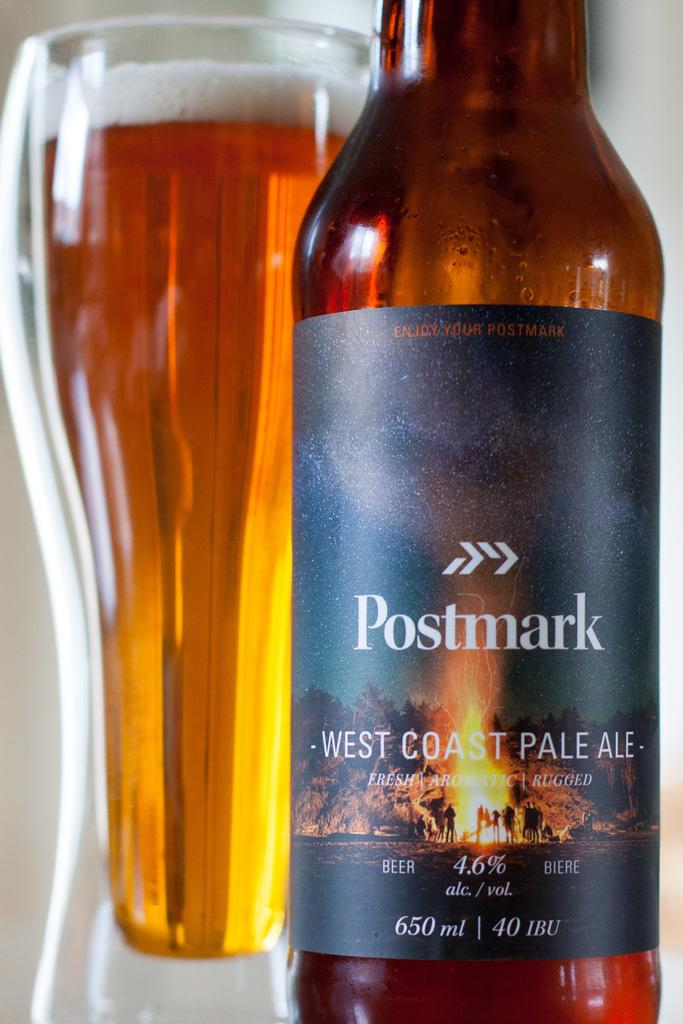<image>
Present a compact description of the photo's key features. A bottle labelled "Postmark" contains a west coast pale ale. 